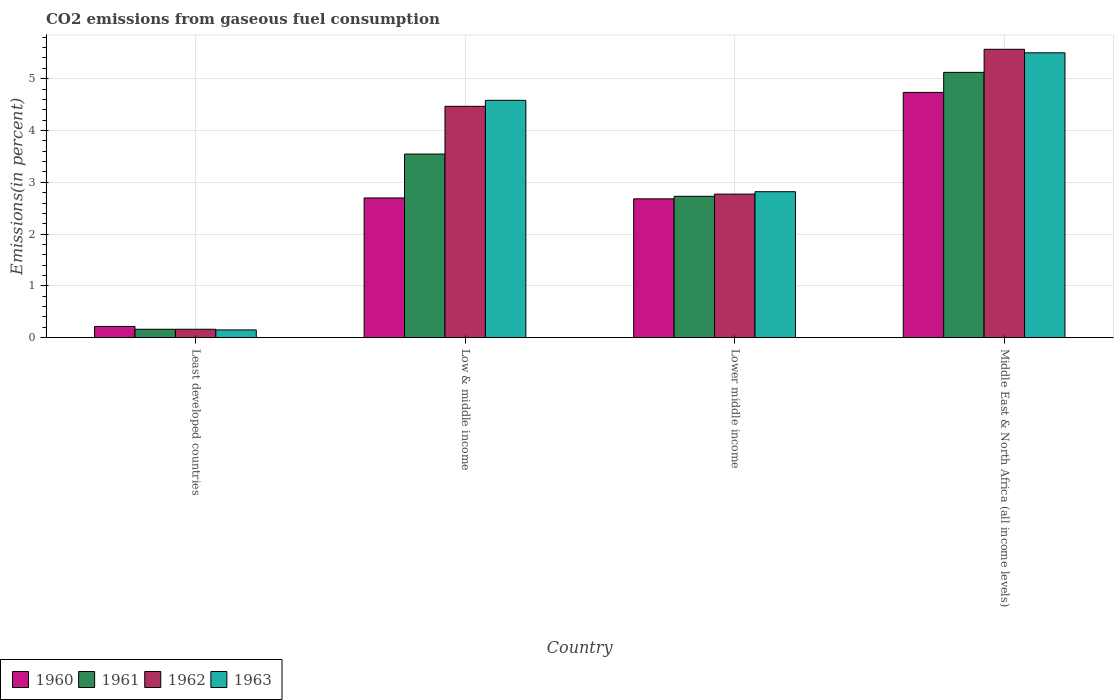Are the number of bars on each tick of the X-axis equal?
Offer a very short reply. Yes. How many bars are there on the 4th tick from the left?
Your answer should be very brief. 4. What is the label of the 2nd group of bars from the left?
Offer a terse response. Low & middle income. What is the total CO2 emitted in 1961 in Least developed countries?
Make the answer very short. 0.16. Across all countries, what is the maximum total CO2 emitted in 1961?
Give a very brief answer. 5.12. Across all countries, what is the minimum total CO2 emitted in 1961?
Provide a short and direct response. 0.16. In which country was the total CO2 emitted in 1961 maximum?
Provide a succinct answer. Middle East & North Africa (all income levels). In which country was the total CO2 emitted in 1960 minimum?
Your answer should be very brief. Least developed countries. What is the total total CO2 emitted in 1961 in the graph?
Make the answer very short. 11.56. What is the difference between the total CO2 emitted in 1961 in Lower middle income and that in Middle East & North Africa (all income levels)?
Make the answer very short. -2.39. What is the difference between the total CO2 emitted in 1963 in Low & middle income and the total CO2 emitted in 1960 in Lower middle income?
Offer a terse response. 1.9. What is the average total CO2 emitted in 1960 per country?
Provide a short and direct response. 2.58. What is the difference between the total CO2 emitted of/in 1960 and total CO2 emitted of/in 1961 in Middle East & North Africa (all income levels)?
Offer a very short reply. -0.39. In how many countries, is the total CO2 emitted in 1960 greater than 0.8 %?
Offer a very short reply. 3. What is the ratio of the total CO2 emitted in 1961 in Least developed countries to that in Middle East & North Africa (all income levels)?
Your answer should be very brief. 0.03. Is the total CO2 emitted in 1962 in Least developed countries less than that in Middle East & North Africa (all income levels)?
Your answer should be very brief. Yes. What is the difference between the highest and the second highest total CO2 emitted in 1961?
Give a very brief answer. -0.82. What is the difference between the highest and the lowest total CO2 emitted in 1960?
Provide a short and direct response. 4.52. Is the sum of the total CO2 emitted in 1962 in Lower middle income and Middle East & North Africa (all income levels) greater than the maximum total CO2 emitted in 1963 across all countries?
Offer a very short reply. Yes. Is it the case that in every country, the sum of the total CO2 emitted in 1962 and total CO2 emitted in 1960 is greater than the sum of total CO2 emitted in 1961 and total CO2 emitted in 1963?
Your response must be concise. No. Are all the bars in the graph horizontal?
Provide a short and direct response. No. Are the values on the major ticks of Y-axis written in scientific E-notation?
Provide a succinct answer. No. Does the graph contain any zero values?
Offer a terse response. No. What is the title of the graph?
Provide a succinct answer. CO2 emissions from gaseous fuel consumption. Does "2003" appear as one of the legend labels in the graph?
Provide a short and direct response. No. What is the label or title of the X-axis?
Your answer should be compact. Country. What is the label or title of the Y-axis?
Offer a very short reply. Emissions(in percent). What is the Emissions(in percent) in 1960 in Least developed countries?
Ensure brevity in your answer.  0.22. What is the Emissions(in percent) of 1961 in Least developed countries?
Offer a terse response. 0.16. What is the Emissions(in percent) in 1962 in Least developed countries?
Your answer should be compact. 0.16. What is the Emissions(in percent) of 1963 in Least developed countries?
Provide a short and direct response. 0.15. What is the Emissions(in percent) in 1960 in Low & middle income?
Your answer should be compact. 2.7. What is the Emissions(in percent) of 1961 in Low & middle income?
Keep it short and to the point. 3.55. What is the Emissions(in percent) of 1962 in Low & middle income?
Ensure brevity in your answer.  4.47. What is the Emissions(in percent) in 1963 in Low & middle income?
Give a very brief answer. 4.58. What is the Emissions(in percent) in 1960 in Lower middle income?
Provide a short and direct response. 2.68. What is the Emissions(in percent) in 1961 in Lower middle income?
Give a very brief answer. 2.73. What is the Emissions(in percent) in 1962 in Lower middle income?
Keep it short and to the point. 2.77. What is the Emissions(in percent) in 1963 in Lower middle income?
Provide a succinct answer. 2.82. What is the Emissions(in percent) of 1960 in Middle East & North Africa (all income levels)?
Make the answer very short. 4.74. What is the Emissions(in percent) of 1961 in Middle East & North Africa (all income levels)?
Your response must be concise. 5.12. What is the Emissions(in percent) of 1962 in Middle East & North Africa (all income levels)?
Offer a very short reply. 5.57. What is the Emissions(in percent) of 1963 in Middle East & North Africa (all income levels)?
Your answer should be compact. 5.5. Across all countries, what is the maximum Emissions(in percent) of 1960?
Make the answer very short. 4.74. Across all countries, what is the maximum Emissions(in percent) in 1961?
Keep it short and to the point. 5.12. Across all countries, what is the maximum Emissions(in percent) in 1962?
Your answer should be very brief. 5.57. Across all countries, what is the maximum Emissions(in percent) of 1963?
Your answer should be compact. 5.5. Across all countries, what is the minimum Emissions(in percent) of 1960?
Your response must be concise. 0.22. Across all countries, what is the minimum Emissions(in percent) of 1961?
Your response must be concise. 0.16. Across all countries, what is the minimum Emissions(in percent) in 1962?
Offer a very short reply. 0.16. Across all countries, what is the minimum Emissions(in percent) of 1963?
Offer a terse response. 0.15. What is the total Emissions(in percent) of 1960 in the graph?
Your response must be concise. 10.33. What is the total Emissions(in percent) of 1961 in the graph?
Make the answer very short. 11.56. What is the total Emissions(in percent) in 1962 in the graph?
Give a very brief answer. 12.97. What is the total Emissions(in percent) of 1963 in the graph?
Offer a terse response. 13.05. What is the difference between the Emissions(in percent) of 1960 in Least developed countries and that in Low & middle income?
Keep it short and to the point. -2.48. What is the difference between the Emissions(in percent) in 1961 in Least developed countries and that in Low & middle income?
Offer a very short reply. -3.38. What is the difference between the Emissions(in percent) of 1962 in Least developed countries and that in Low & middle income?
Keep it short and to the point. -4.31. What is the difference between the Emissions(in percent) of 1963 in Least developed countries and that in Low & middle income?
Keep it short and to the point. -4.43. What is the difference between the Emissions(in percent) of 1960 in Least developed countries and that in Lower middle income?
Keep it short and to the point. -2.46. What is the difference between the Emissions(in percent) in 1961 in Least developed countries and that in Lower middle income?
Your response must be concise. -2.57. What is the difference between the Emissions(in percent) of 1962 in Least developed countries and that in Lower middle income?
Offer a very short reply. -2.61. What is the difference between the Emissions(in percent) of 1963 in Least developed countries and that in Lower middle income?
Offer a terse response. -2.67. What is the difference between the Emissions(in percent) of 1960 in Least developed countries and that in Middle East & North Africa (all income levels)?
Your response must be concise. -4.52. What is the difference between the Emissions(in percent) in 1961 in Least developed countries and that in Middle East & North Africa (all income levels)?
Your response must be concise. -4.96. What is the difference between the Emissions(in percent) of 1962 in Least developed countries and that in Middle East & North Africa (all income levels)?
Offer a very short reply. -5.41. What is the difference between the Emissions(in percent) in 1963 in Least developed countries and that in Middle East & North Africa (all income levels)?
Provide a succinct answer. -5.35. What is the difference between the Emissions(in percent) in 1960 in Low & middle income and that in Lower middle income?
Ensure brevity in your answer.  0.02. What is the difference between the Emissions(in percent) in 1961 in Low & middle income and that in Lower middle income?
Give a very brief answer. 0.82. What is the difference between the Emissions(in percent) in 1962 in Low & middle income and that in Lower middle income?
Make the answer very short. 1.7. What is the difference between the Emissions(in percent) of 1963 in Low & middle income and that in Lower middle income?
Your response must be concise. 1.76. What is the difference between the Emissions(in percent) in 1960 in Low & middle income and that in Middle East & North Africa (all income levels)?
Offer a very short reply. -2.04. What is the difference between the Emissions(in percent) of 1961 in Low & middle income and that in Middle East & North Africa (all income levels)?
Offer a terse response. -1.58. What is the difference between the Emissions(in percent) in 1962 in Low & middle income and that in Middle East & North Africa (all income levels)?
Your answer should be very brief. -1.1. What is the difference between the Emissions(in percent) of 1963 in Low & middle income and that in Middle East & North Africa (all income levels)?
Your response must be concise. -0.92. What is the difference between the Emissions(in percent) in 1960 in Lower middle income and that in Middle East & North Africa (all income levels)?
Offer a very short reply. -2.06. What is the difference between the Emissions(in percent) of 1961 in Lower middle income and that in Middle East & North Africa (all income levels)?
Make the answer very short. -2.39. What is the difference between the Emissions(in percent) in 1962 in Lower middle income and that in Middle East & North Africa (all income levels)?
Offer a terse response. -2.8. What is the difference between the Emissions(in percent) of 1963 in Lower middle income and that in Middle East & North Africa (all income levels)?
Provide a short and direct response. -2.68. What is the difference between the Emissions(in percent) of 1960 in Least developed countries and the Emissions(in percent) of 1961 in Low & middle income?
Your response must be concise. -3.33. What is the difference between the Emissions(in percent) in 1960 in Least developed countries and the Emissions(in percent) in 1962 in Low & middle income?
Make the answer very short. -4.25. What is the difference between the Emissions(in percent) in 1960 in Least developed countries and the Emissions(in percent) in 1963 in Low & middle income?
Make the answer very short. -4.37. What is the difference between the Emissions(in percent) of 1961 in Least developed countries and the Emissions(in percent) of 1962 in Low & middle income?
Provide a succinct answer. -4.31. What is the difference between the Emissions(in percent) of 1961 in Least developed countries and the Emissions(in percent) of 1963 in Low & middle income?
Ensure brevity in your answer.  -4.42. What is the difference between the Emissions(in percent) of 1962 in Least developed countries and the Emissions(in percent) of 1963 in Low & middle income?
Make the answer very short. -4.42. What is the difference between the Emissions(in percent) of 1960 in Least developed countries and the Emissions(in percent) of 1961 in Lower middle income?
Your answer should be compact. -2.51. What is the difference between the Emissions(in percent) of 1960 in Least developed countries and the Emissions(in percent) of 1962 in Lower middle income?
Your answer should be very brief. -2.56. What is the difference between the Emissions(in percent) in 1960 in Least developed countries and the Emissions(in percent) in 1963 in Lower middle income?
Provide a succinct answer. -2.6. What is the difference between the Emissions(in percent) of 1961 in Least developed countries and the Emissions(in percent) of 1962 in Lower middle income?
Offer a very short reply. -2.61. What is the difference between the Emissions(in percent) of 1961 in Least developed countries and the Emissions(in percent) of 1963 in Lower middle income?
Give a very brief answer. -2.66. What is the difference between the Emissions(in percent) of 1962 in Least developed countries and the Emissions(in percent) of 1963 in Lower middle income?
Your answer should be very brief. -2.66. What is the difference between the Emissions(in percent) of 1960 in Least developed countries and the Emissions(in percent) of 1961 in Middle East & North Africa (all income levels)?
Provide a succinct answer. -4.91. What is the difference between the Emissions(in percent) in 1960 in Least developed countries and the Emissions(in percent) in 1962 in Middle East & North Africa (all income levels)?
Make the answer very short. -5.35. What is the difference between the Emissions(in percent) in 1960 in Least developed countries and the Emissions(in percent) in 1963 in Middle East & North Africa (all income levels)?
Give a very brief answer. -5.28. What is the difference between the Emissions(in percent) in 1961 in Least developed countries and the Emissions(in percent) in 1962 in Middle East & North Africa (all income levels)?
Provide a succinct answer. -5.41. What is the difference between the Emissions(in percent) of 1961 in Least developed countries and the Emissions(in percent) of 1963 in Middle East & North Africa (all income levels)?
Offer a very short reply. -5.34. What is the difference between the Emissions(in percent) of 1962 in Least developed countries and the Emissions(in percent) of 1963 in Middle East & North Africa (all income levels)?
Give a very brief answer. -5.34. What is the difference between the Emissions(in percent) of 1960 in Low & middle income and the Emissions(in percent) of 1961 in Lower middle income?
Ensure brevity in your answer.  -0.03. What is the difference between the Emissions(in percent) in 1960 in Low & middle income and the Emissions(in percent) in 1962 in Lower middle income?
Offer a terse response. -0.07. What is the difference between the Emissions(in percent) of 1960 in Low & middle income and the Emissions(in percent) of 1963 in Lower middle income?
Ensure brevity in your answer.  -0.12. What is the difference between the Emissions(in percent) in 1961 in Low & middle income and the Emissions(in percent) in 1962 in Lower middle income?
Keep it short and to the point. 0.77. What is the difference between the Emissions(in percent) in 1961 in Low & middle income and the Emissions(in percent) in 1963 in Lower middle income?
Offer a very short reply. 0.73. What is the difference between the Emissions(in percent) in 1962 in Low & middle income and the Emissions(in percent) in 1963 in Lower middle income?
Provide a short and direct response. 1.65. What is the difference between the Emissions(in percent) in 1960 in Low & middle income and the Emissions(in percent) in 1961 in Middle East & North Africa (all income levels)?
Provide a short and direct response. -2.42. What is the difference between the Emissions(in percent) in 1960 in Low & middle income and the Emissions(in percent) in 1962 in Middle East & North Africa (all income levels)?
Your response must be concise. -2.87. What is the difference between the Emissions(in percent) of 1960 in Low & middle income and the Emissions(in percent) of 1963 in Middle East & North Africa (all income levels)?
Offer a very short reply. -2.8. What is the difference between the Emissions(in percent) of 1961 in Low & middle income and the Emissions(in percent) of 1962 in Middle East & North Africa (all income levels)?
Provide a succinct answer. -2.02. What is the difference between the Emissions(in percent) of 1961 in Low & middle income and the Emissions(in percent) of 1963 in Middle East & North Africa (all income levels)?
Offer a very short reply. -1.95. What is the difference between the Emissions(in percent) of 1962 in Low & middle income and the Emissions(in percent) of 1963 in Middle East & North Africa (all income levels)?
Offer a terse response. -1.03. What is the difference between the Emissions(in percent) in 1960 in Lower middle income and the Emissions(in percent) in 1961 in Middle East & North Africa (all income levels)?
Make the answer very short. -2.44. What is the difference between the Emissions(in percent) of 1960 in Lower middle income and the Emissions(in percent) of 1962 in Middle East & North Africa (all income levels)?
Provide a succinct answer. -2.89. What is the difference between the Emissions(in percent) of 1960 in Lower middle income and the Emissions(in percent) of 1963 in Middle East & North Africa (all income levels)?
Keep it short and to the point. -2.82. What is the difference between the Emissions(in percent) in 1961 in Lower middle income and the Emissions(in percent) in 1962 in Middle East & North Africa (all income levels)?
Ensure brevity in your answer.  -2.84. What is the difference between the Emissions(in percent) in 1961 in Lower middle income and the Emissions(in percent) in 1963 in Middle East & North Africa (all income levels)?
Give a very brief answer. -2.77. What is the difference between the Emissions(in percent) of 1962 in Lower middle income and the Emissions(in percent) of 1963 in Middle East & North Africa (all income levels)?
Your answer should be very brief. -2.73. What is the average Emissions(in percent) in 1960 per country?
Your response must be concise. 2.58. What is the average Emissions(in percent) of 1961 per country?
Keep it short and to the point. 2.89. What is the average Emissions(in percent) in 1962 per country?
Keep it short and to the point. 3.24. What is the average Emissions(in percent) in 1963 per country?
Your answer should be compact. 3.26. What is the difference between the Emissions(in percent) in 1960 and Emissions(in percent) in 1961 in Least developed countries?
Give a very brief answer. 0.05. What is the difference between the Emissions(in percent) of 1960 and Emissions(in percent) of 1962 in Least developed countries?
Offer a terse response. 0.05. What is the difference between the Emissions(in percent) of 1960 and Emissions(in percent) of 1963 in Least developed countries?
Your answer should be compact. 0.07. What is the difference between the Emissions(in percent) in 1961 and Emissions(in percent) in 1962 in Least developed countries?
Ensure brevity in your answer.  -0. What is the difference between the Emissions(in percent) in 1961 and Emissions(in percent) in 1963 in Least developed countries?
Offer a very short reply. 0.01. What is the difference between the Emissions(in percent) in 1962 and Emissions(in percent) in 1963 in Least developed countries?
Make the answer very short. 0.01. What is the difference between the Emissions(in percent) of 1960 and Emissions(in percent) of 1961 in Low & middle income?
Keep it short and to the point. -0.85. What is the difference between the Emissions(in percent) in 1960 and Emissions(in percent) in 1962 in Low & middle income?
Your response must be concise. -1.77. What is the difference between the Emissions(in percent) of 1960 and Emissions(in percent) of 1963 in Low & middle income?
Provide a succinct answer. -1.88. What is the difference between the Emissions(in percent) in 1961 and Emissions(in percent) in 1962 in Low & middle income?
Ensure brevity in your answer.  -0.92. What is the difference between the Emissions(in percent) of 1961 and Emissions(in percent) of 1963 in Low & middle income?
Offer a very short reply. -1.04. What is the difference between the Emissions(in percent) of 1962 and Emissions(in percent) of 1963 in Low & middle income?
Offer a very short reply. -0.12. What is the difference between the Emissions(in percent) in 1960 and Emissions(in percent) in 1961 in Lower middle income?
Your response must be concise. -0.05. What is the difference between the Emissions(in percent) in 1960 and Emissions(in percent) in 1962 in Lower middle income?
Your answer should be very brief. -0.09. What is the difference between the Emissions(in percent) in 1960 and Emissions(in percent) in 1963 in Lower middle income?
Your response must be concise. -0.14. What is the difference between the Emissions(in percent) in 1961 and Emissions(in percent) in 1962 in Lower middle income?
Offer a terse response. -0.04. What is the difference between the Emissions(in percent) of 1961 and Emissions(in percent) of 1963 in Lower middle income?
Keep it short and to the point. -0.09. What is the difference between the Emissions(in percent) of 1962 and Emissions(in percent) of 1963 in Lower middle income?
Offer a terse response. -0.05. What is the difference between the Emissions(in percent) of 1960 and Emissions(in percent) of 1961 in Middle East & North Africa (all income levels)?
Make the answer very short. -0.39. What is the difference between the Emissions(in percent) of 1960 and Emissions(in percent) of 1962 in Middle East & North Africa (all income levels)?
Provide a short and direct response. -0.83. What is the difference between the Emissions(in percent) in 1960 and Emissions(in percent) in 1963 in Middle East & North Africa (all income levels)?
Give a very brief answer. -0.76. What is the difference between the Emissions(in percent) of 1961 and Emissions(in percent) of 1962 in Middle East & North Africa (all income levels)?
Your answer should be very brief. -0.45. What is the difference between the Emissions(in percent) in 1961 and Emissions(in percent) in 1963 in Middle East & North Africa (all income levels)?
Provide a succinct answer. -0.38. What is the difference between the Emissions(in percent) in 1962 and Emissions(in percent) in 1963 in Middle East & North Africa (all income levels)?
Provide a succinct answer. 0.07. What is the ratio of the Emissions(in percent) in 1960 in Least developed countries to that in Low & middle income?
Provide a succinct answer. 0.08. What is the ratio of the Emissions(in percent) in 1961 in Least developed countries to that in Low & middle income?
Give a very brief answer. 0.05. What is the ratio of the Emissions(in percent) in 1962 in Least developed countries to that in Low & middle income?
Make the answer very short. 0.04. What is the ratio of the Emissions(in percent) in 1963 in Least developed countries to that in Low & middle income?
Your response must be concise. 0.03. What is the ratio of the Emissions(in percent) in 1960 in Least developed countries to that in Lower middle income?
Your answer should be compact. 0.08. What is the ratio of the Emissions(in percent) in 1961 in Least developed countries to that in Lower middle income?
Offer a terse response. 0.06. What is the ratio of the Emissions(in percent) of 1962 in Least developed countries to that in Lower middle income?
Keep it short and to the point. 0.06. What is the ratio of the Emissions(in percent) of 1963 in Least developed countries to that in Lower middle income?
Offer a terse response. 0.05. What is the ratio of the Emissions(in percent) of 1960 in Least developed countries to that in Middle East & North Africa (all income levels)?
Your answer should be very brief. 0.05. What is the ratio of the Emissions(in percent) in 1961 in Least developed countries to that in Middle East & North Africa (all income levels)?
Your answer should be very brief. 0.03. What is the ratio of the Emissions(in percent) in 1962 in Least developed countries to that in Middle East & North Africa (all income levels)?
Offer a very short reply. 0.03. What is the ratio of the Emissions(in percent) of 1963 in Least developed countries to that in Middle East & North Africa (all income levels)?
Provide a short and direct response. 0.03. What is the ratio of the Emissions(in percent) in 1960 in Low & middle income to that in Lower middle income?
Offer a very short reply. 1.01. What is the ratio of the Emissions(in percent) in 1961 in Low & middle income to that in Lower middle income?
Provide a short and direct response. 1.3. What is the ratio of the Emissions(in percent) in 1962 in Low & middle income to that in Lower middle income?
Your response must be concise. 1.61. What is the ratio of the Emissions(in percent) in 1963 in Low & middle income to that in Lower middle income?
Keep it short and to the point. 1.63. What is the ratio of the Emissions(in percent) of 1960 in Low & middle income to that in Middle East & North Africa (all income levels)?
Keep it short and to the point. 0.57. What is the ratio of the Emissions(in percent) of 1961 in Low & middle income to that in Middle East & North Africa (all income levels)?
Your answer should be very brief. 0.69. What is the ratio of the Emissions(in percent) in 1962 in Low & middle income to that in Middle East & North Africa (all income levels)?
Ensure brevity in your answer.  0.8. What is the ratio of the Emissions(in percent) in 1963 in Low & middle income to that in Middle East & North Africa (all income levels)?
Make the answer very short. 0.83. What is the ratio of the Emissions(in percent) of 1960 in Lower middle income to that in Middle East & North Africa (all income levels)?
Make the answer very short. 0.57. What is the ratio of the Emissions(in percent) in 1961 in Lower middle income to that in Middle East & North Africa (all income levels)?
Give a very brief answer. 0.53. What is the ratio of the Emissions(in percent) in 1962 in Lower middle income to that in Middle East & North Africa (all income levels)?
Provide a succinct answer. 0.5. What is the ratio of the Emissions(in percent) of 1963 in Lower middle income to that in Middle East & North Africa (all income levels)?
Offer a terse response. 0.51. What is the difference between the highest and the second highest Emissions(in percent) of 1960?
Your answer should be very brief. 2.04. What is the difference between the highest and the second highest Emissions(in percent) of 1961?
Offer a terse response. 1.58. What is the difference between the highest and the second highest Emissions(in percent) of 1962?
Make the answer very short. 1.1. What is the difference between the highest and the second highest Emissions(in percent) of 1963?
Give a very brief answer. 0.92. What is the difference between the highest and the lowest Emissions(in percent) of 1960?
Ensure brevity in your answer.  4.52. What is the difference between the highest and the lowest Emissions(in percent) of 1961?
Keep it short and to the point. 4.96. What is the difference between the highest and the lowest Emissions(in percent) of 1962?
Your response must be concise. 5.41. What is the difference between the highest and the lowest Emissions(in percent) in 1963?
Ensure brevity in your answer.  5.35. 